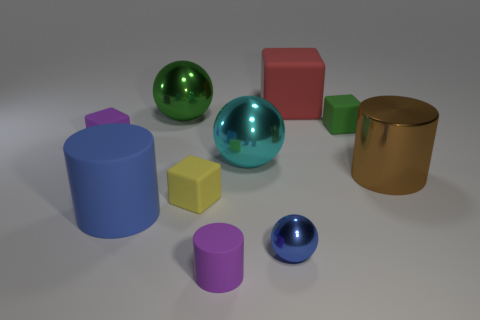Subtract all large metallic cylinders. How many cylinders are left? 2 Subtract all balls. How many objects are left? 7 Subtract 1 balls. How many balls are left? 2 Add 1 tiny rubber objects. How many tiny rubber objects exist? 5 Subtract all blue spheres. How many spheres are left? 2 Subtract 0 blue blocks. How many objects are left? 10 Subtract all red balls. Subtract all green blocks. How many balls are left? 3 Subtract all brown cylinders. How many purple blocks are left? 1 Subtract all purple metallic cylinders. Subtract all spheres. How many objects are left? 7 Add 4 small purple blocks. How many small purple blocks are left? 5 